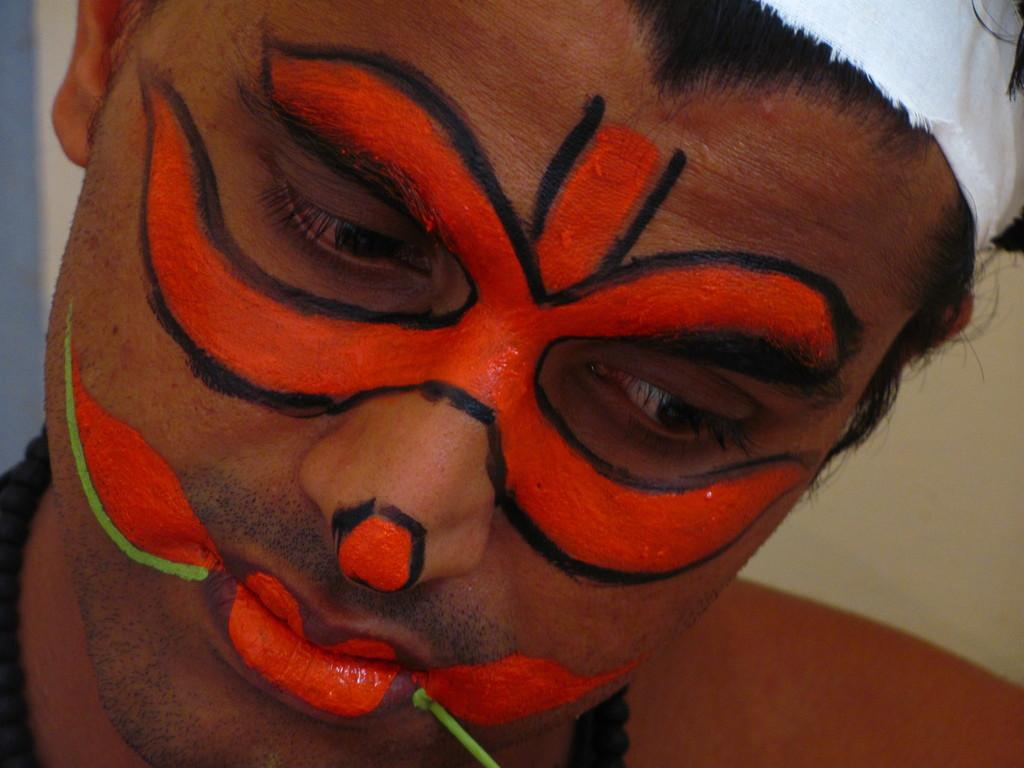What is the main subject of the image? There is a person in the image. Can you describe the background of the image? There is a wall visible behind the person. What type of skirt is the person wearing in the image? There is no skirt visible in the image; the person's clothing is not described in the provided facts. What type of iron can be seen in the image? There is no iron present in the image. 